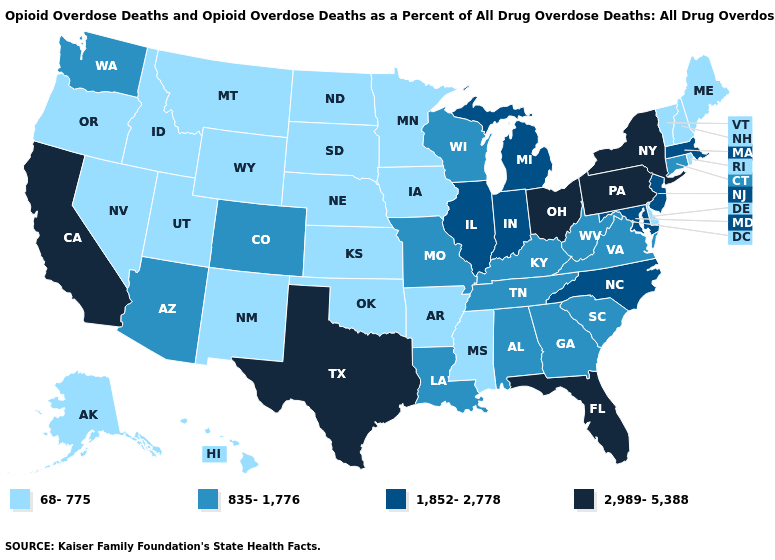Name the states that have a value in the range 835-1,776?
Write a very short answer. Alabama, Arizona, Colorado, Connecticut, Georgia, Kentucky, Louisiana, Missouri, South Carolina, Tennessee, Virginia, Washington, West Virginia, Wisconsin. What is the value of Illinois?
Answer briefly. 1,852-2,778. How many symbols are there in the legend?
Short answer required. 4. Name the states that have a value in the range 2,989-5,388?
Keep it brief. California, Florida, New York, Ohio, Pennsylvania, Texas. Name the states that have a value in the range 835-1,776?
Be succinct. Alabama, Arizona, Colorado, Connecticut, Georgia, Kentucky, Louisiana, Missouri, South Carolina, Tennessee, Virginia, Washington, West Virginia, Wisconsin. Among the states that border Tennessee , which have the lowest value?
Keep it brief. Arkansas, Mississippi. What is the highest value in states that border Arkansas?
Concise answer only. 2,989-5,388. Which states have the lowest value in the USA?
Be succinct. Alaska, Arkansas, Delaware, Hawaii, Idaho, Iowa, Kansas, Maine, Minnesota, Mississippi, Montana, Nebraska, Nevada, New Hampshire, New Mexico, North Dakota, Oklahoma, Oregon, Rhode Island, South Dakota, Utah, Vermont, Wyoming. Which states have the lowest value in the USA?
Answer briefly. Alaska, Arkansas, Delaware, Hawaii, Idaho, Iowa, Kansas, Maine, Minnesota, Mississippi, Montana, Nebraska, Nevada, New Hampshire, New Mexico, North Dakota, Oklahoma, Oregon, Rhode Island, South Dakota, Utah, Vermont, Wyoming. Does New Mexico have a lower value than Maine?
Quick response, please. No. Name the states that have a value in the range 1,852-2,778?
Write a very short answer. Illinois, Indiana, Maryland, Massachusetts, Michigan, New Jersey, North Carolina. What is the highest value in the USA?
Keep it brief. 2,989-5,388. Name the states that have a value in the range 835-1,776?
Be succinct. Alabama, Arizona, Colorado, Connecticut, Georgia, Kentucky, Louisiana, Missouri, South Carolina, Tennessee, Virginia, Washington, West Virginia, Wisconsin. Name the states that have a value in the range 2,989-5,388?
Give a very brief answer. California, Florida, New York, Ohio, Pennsylvania, Texas. 